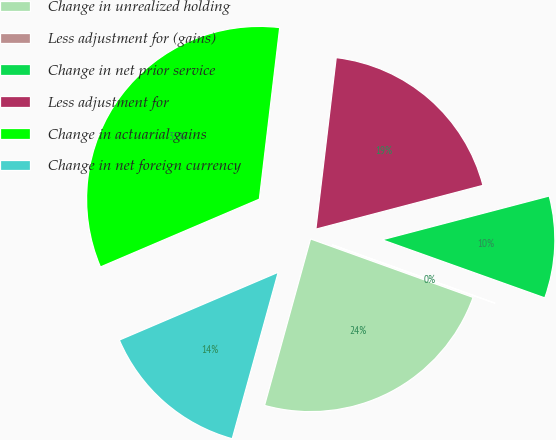Convert chart to OTSL. <chart><loc_0><loc_0><loc_500><loc_500><pie_chart><fcel>Change in unrealized holding<fcel>Less adjustment for (gains)<fcel>Change in net prior service<fcel>Less adjustment for<fcel>Change in actuarial gains<fcel>Change in net foreign currency<nl><fcel>23.79%<fcel>0.04%<fcel>9.54%<fcel>19.04%<fcel>33.3%<fcel>14.29%<nl></chart> 